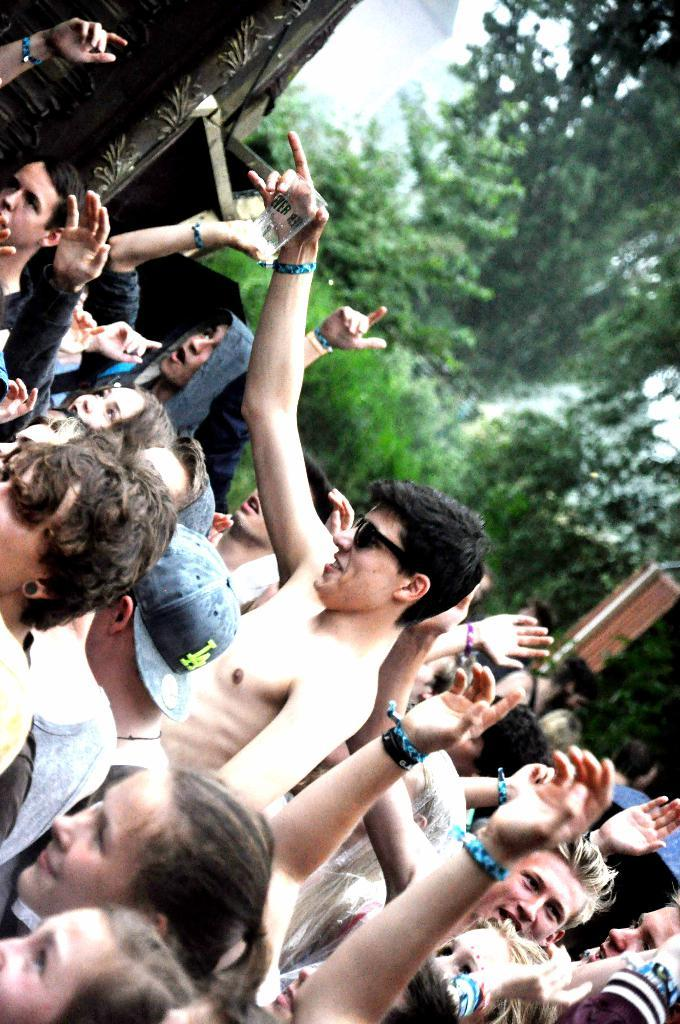How many people are in the image? There is a group of people in the image. What are the people in the image doing? The people are standing. What type of natural elements can be seen in the image? There are trees in the image. What type of man-made structures can be seen in the image? There are buildings in the image. What type of spark can be seen coming from the trees in the image? There is no spark present in the image; it features a group of people standing, trees, and buildings. 